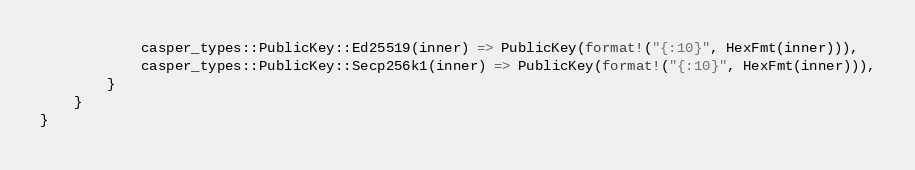<code> <loc_0><loc_0><loc_500><loc_500><_Rust_>            casper_types::PublicKey::Ed25519(inner) => PublicKey(format!("{:10}", HexFmt(inner))),
            casper_types::PublicKey::Secp256k1(inner) => PublicKey(format!("{:10}", HexFmt(inner))),
        }
    }
}
</code> 